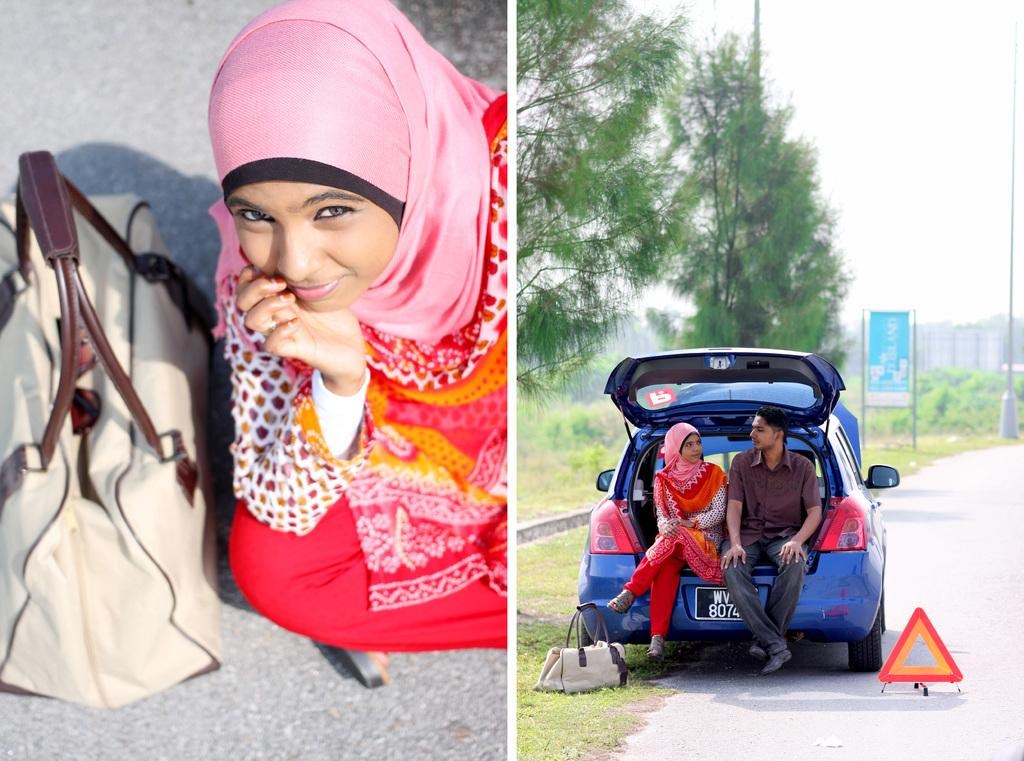What are the people in the image doing? The two people are sitting in a car. What can be seen on the road in the image? There is a bag on the road. Can you describe the objects at the back side of the image? There are three unspecified objects at the back side. What is the board used for in the image? The board's purpose is not specified in the image. What month is it in the image? The month is not specified in the image. Can you tell me how many gloves are visible in the image? There are no gloves present in the image. 